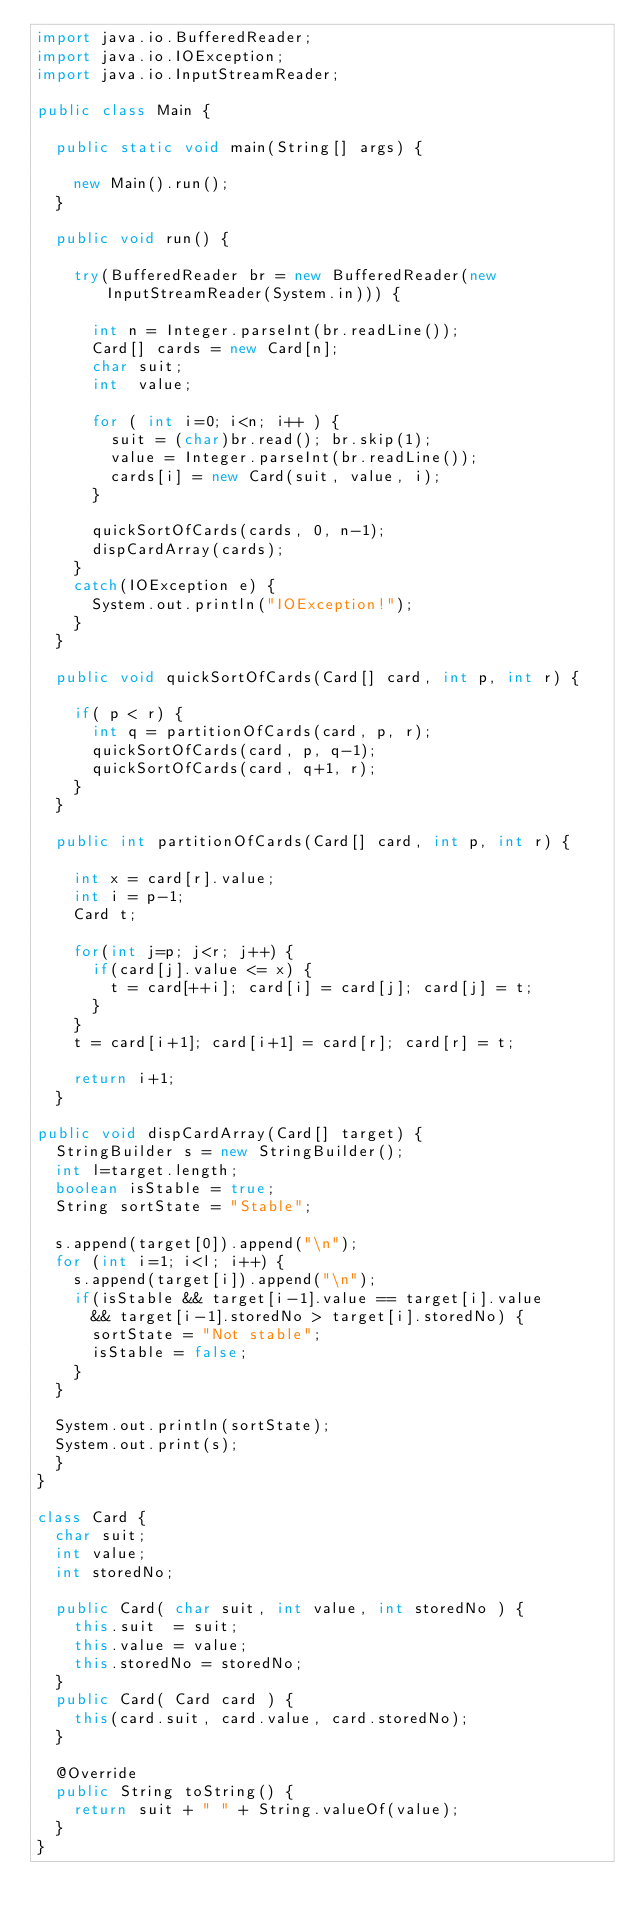Convert code to text. <code><loc_0><loc_0><loc_500><loc_500><_Java_>import java.io.BufferedReader;
import java.io.IOException;
import java.io.InputStreamReader;

public class Main {

  public static void main(String[] args) {
  
    new Main().run();
  }

  public void run() {

    try(BufferedReader br = new BufferedReader(new InputStreamReader(System.in))) {

      int n = Integer.parseInt(br.readLine());
      Card[] cards = new Card[n];
      char suit;
      int  value;

      for ( int i=0; i<n; i++ ) {
        suit = (char)br.read(); br.skip(1);
        value = Integer.parseInt(br.readLine());
        cards[i] = new Card(suit, value, i);
      }

      quickSortOfCards(cards, 0, n-1);
      dispCardArray(cards);
    }
    catch(IOException e) {
      System.out.println("IOException!");
    }
  }

  public void quickSortOfCards(Card[] card, int p, int r) {

    if( p < r) {
      int q = partitionOfCards(card, p, r);
      quickSortOfCards(card, p, q-1);
      quickSortOfCards(card, q+1, r);
    }
  }

  public int partitionOfCards(Card[] card, int p, int r) {

    int x = card[r].value;
    int i = p-1;
    Card t;

    for(int j=p; j<r; j++) {
      if(card[j].value <= x) {
        t = card[++i]; card[i] = card[j]; card[j] = t;
      }
    }
    t = card[i+1]; card[i+1] = card[r]; card[r] = t;

    return i+1;
  }

public void dispCardArray(Card[] target) {
  StringBuilder s = new StringBuilder();
  int l=target.length;
  boolean isStable = true;
  String sortState = "Stable";

  s.append(target[0]).append("\n");
  for (int i=1; i<l; i++) {
    s.append(target[i]).append("\n");
    if(isStable && target[i-1].value == target[i].value 
      && target[i-1].storedNo > target[i].storedNo) {
      sortState = "Not stable";
      isStable = false;
    }
  }

  System.out.println(sortState);
  System.out.print(s);
  }
}

class Card {
  char suit;
  int value;
  int storedNo;

  public Card( char suit, int value, int storedNo ) {
    this.suit  = suit;
    this.value = value;
    this.storedNo = storedNo;
  }
  public Card( Card card ) {
    this(card.suit, card.value, card.storedNo);
  }

  @Override
  public String toString() {
    return suit + " " + String.valueOf(value);
  }
}
</code> 